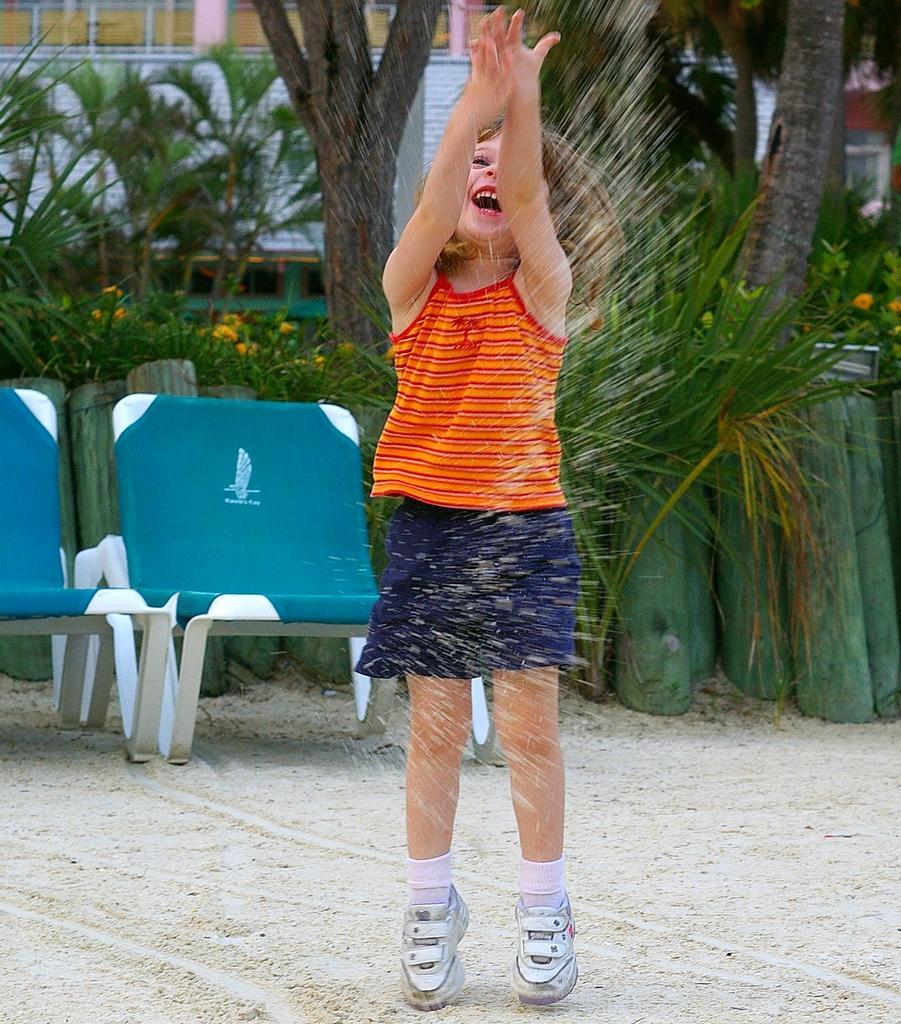How would you summarize this image in a sentence or two? In the picture,the girl is playing with the sand she is wearing blue and orange dress,behind the girl there are two chairs and behind the chairs there are some trees and plants. 